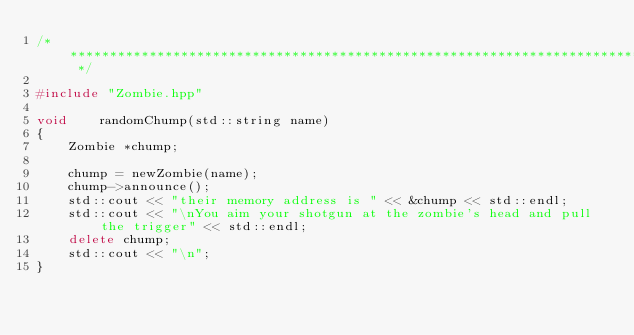Convert code to text. <code><loc_0><loc_0><loc_500><loc_500><_C++_>/* ************************************************************************** */

#include "Zombie.hpp"

void	randomChump(std::string name)
{
	Zombie *chump;

	chump = newZombie(name);
	chump->announce();
	std::cout << "their memory address is " << &chump << std::endl;
	std::cout << "\nYou aim your shotgun at the zombie's head and pull the trigger" << std::endl;
	delete chump;
	std::cout << "\n";
}</code> 